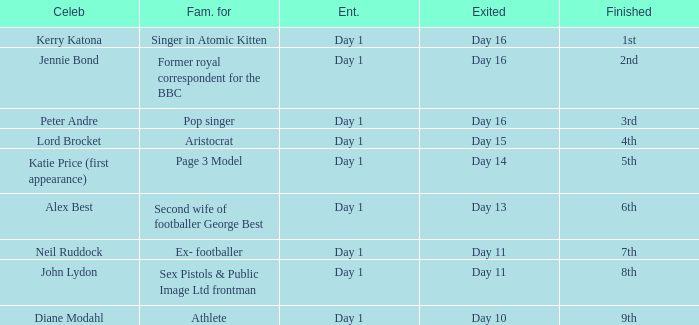Write the full table. {'header': ['Celeb', 'Fam. for', 'Ent.', 'Exited', 'Finished'], 'rows': [['Kerry Katona', 'Singer in Atomic Kitten', 'Day 1', 'Day 16', '1st'], ['Jennie Bond', 'Former royal correspondent for the BBC', 'Day 1', 'Day 16', '2nd'], ['Peter Andre', 'Pop singer', 'Day 1', 'Day 16', '3rd'], ['Lord Brocket', 'Aristocrat', 'Day 1', 'Day 15', '4th'], ['Katie Price (first appearance)', 'Page 3 Model', 'Day 1', 'Day 14', '5th'], ['Alex Best', 'Second wife of footballer George Best', 'Day 1', 'Day 13', '6th'], ['Neil Ruddock', 'Ex- footballer', 'Day 1', 'Day 11', '7th'], ['John Lydon', 'Sex Pistols & Public Image Ltd frontman', 'Day 1', 'Day 11', '8th'], ['Diane Modahl', 'Athlete', 'Day 1', 'Day 10', '9th']]} Name the number of celebrity for athlete 1.0. 